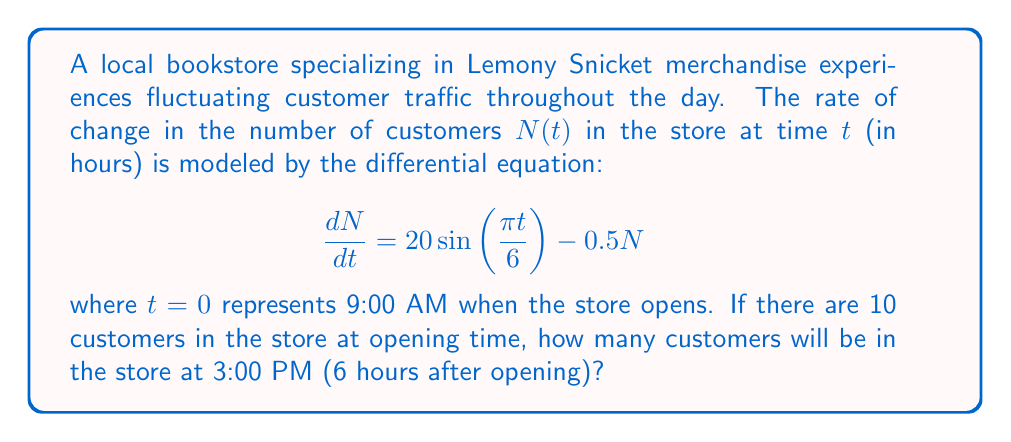Give your solution to this math problem. To solve this problem, we need to find the general solution to the given differential equation and then apply the initial condition to find the particular solution.

1) The general solution to this type of differential equation is:

   $N(t) = e^{-0.5t}(C + \int 20\sin(\frac{\pi t}{6})e^{0.5t}dt)$

2) To evaluate the integral, we use integration by parts:

   $\int 20\sin(\frac{\pi t}{6})e^{0.5t}dt = -\frac{120}{\pi^2+9}(\pi\cos(\frac{\pi t}{6}) - 3\sin(\frac{\pi t}{6}))e^{0.5t} + C_1$

3) Substituting this back into our general solution:

   $N(t) = \frac{120}{\pi^2+9}(\pi\cos(\frac{\pi t}{6}) - 3\sin(\frac{\pi t}{6})) + Ce^{-0.5t}$

4) Now we apply the initial condition: $N(0) = 10$

   $10 = \frac{120\pi}{\pi^2+9} + C$

   $C = 10 - \frac{120\pi}{\pi^2+9}$

5) Our particular solution is:

   $N(t) = \frac{120}{\pi^2+9}(\pi\cos(\frac{\pi t}{6}) - 3\sin(\frac{\pi t}{6})) + (10 - \frac{120\pi}{\pi^2+9})e^{-0.5t}$

6) To find the number of customers at 3:00 PM, we evaluate $N(6)$:

   $N(6) = \frac{120}{\pi^2+9}(\pi\cos(\pi) - 3\sin(\pi)) + (10 - \frac{120\pi}{\pi^2+9})e^{-3}$

7) Simplifying:

   $N(6) = -\frac{120\pi}{\pi^2+9} + (10 - \frac{120\pi}{\pi^2+9})e^{-3}$

8) Evaluating this numerically:

   $N(6) \approx 21.57$
Answer: Approximately 22 customers (rounded to the nearest whole number) will be in the store at 3:00 PM. 